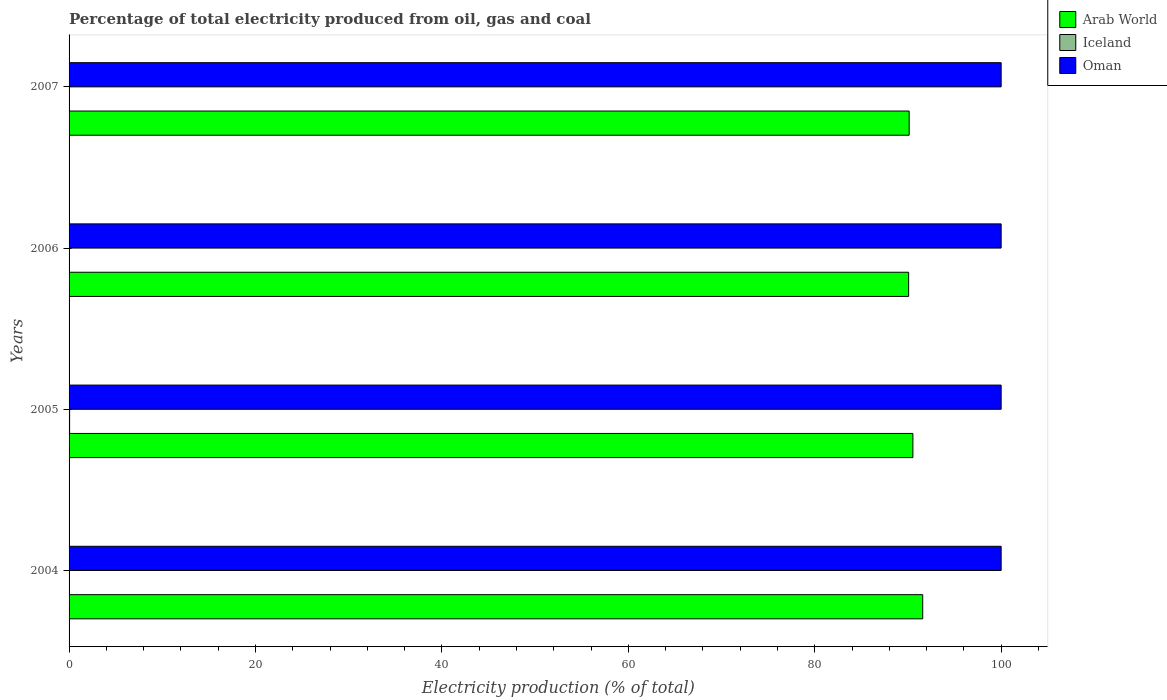Are the number of bars per tick equal to the number of legend labels?
Offer a very short reply. Yes. What is the label of the 1st group of bars from the top?
Your answer should be compact. 2007. What is the electricity production in in Iceland in 2007?
Provide a short and direct response. 0.02. Across all years, what is the minimum electricity production in in Arab World?
Keep it short and to the point. 90.07. In which year was the electricity production in in Iceland minimum?
Your answer should be compact. 2007. What is the total electricity production in in Arab World in the graph?
Keep it short and to the point. 362.32. What is the difference between the electricity production in in Iceland in 2004 and the electricity production in in Arab World in 2005?
Your response must be concise. -90.48. In the year 2007, what is the difference between the electricity production in in Arab World and electricity production in in Iceland?
Keep it short and to the point. 90.11. What is the ratio of the electricity production in in Arab World in 2004 to that in 2007?
Make the answer very short. 1.02. Is the difference between the electricity production in in Arab World in 2004 and 2005 greater than the difference between the electricity production in in Iceland in 2004 and 2005?
Your answer should be very brief. Yes. What is the difference between the highest and the second highest electricity production in in Arab World?
Offer a very short reply. 1.05. What is the difference between the highest and the lowest electricity production in in Oman?
Offer a very short reply. 0. What does the 3rd bar from the top in 2004 represents?
Your response must be concise. Arab World. What does the 1st bar from the bottom in 2004 represents?
Your answer should be very brief. Arab World. Is it the case that in every year, the sum of the electricity production in in Oman and electricity production in in Arab World is greater than the electricity production in in Iceland?
Offer a terse response. Yes. Are the values on the major ticks of X-axis written in scientific E-notation?
Provide a short and direct response. No. Does the graph contain grids?
Make the answer very short. No. What is the title of the graph?
Offer a terse response. Percentage of total electricity produced from oil, gas and coal. What is the label or title of the X-axis?
Your response must be concise. Electricity production (% of total). What is the label or title of the Y-axis?
Make the answer very short. Years. What is the Electricity production (% of total) of Arab World in 2004?
Provide a short and direct response. 91.59. What is the Electricity production (% of total) in Iceland in 2004?
Ensure brevity in your answer.  0.05. What is the Electricity production (% of total) of Oman in 2004?
Ensure brevity in your answer.  100. What is the Electricity production (% of total) in Arab World in 2005?
Keep it short and to the point. 90.53. What is the Electricity production (% of total) of Iceland in 2005?
Your answer should be compact. 0.06. What is the Electricity production (% of total) in Arab World in 2006?
Your response must be concise. 90.07. What is the Electricity production (% of total) in Iceland in 2006?
Make the answer very short. 0.04. What is the Electricity production (% of total) of Oman in 2006?
Your response must be concise. 100. What is the Electricity production (% of total) in Arab World in 2007?
Your response must be concise. 90.13. What is the Electricity production (% of total) of Iceland in 2007?
Keep it short and to the point. 0.02. Across all years, what is the maximum Electricity production (% of total) of Arab World?
Offer a terse response. 91.59. Across all years, what is the maximum Electricity production (% of total) of Iceland?
Give a very brief answer. 0.06. Across all years, what is the maximum Electricity production (% of total) in Oman?
Offer a very short reply. 100. Across all years, what is the minimum Electricity production (% of total) of Arab World?
Give a very brief answer. 90.07. Across all years, what is the minimum Electricity production (% of total) of Iceland?
Your answer should be very brief. 0.02. Across all years, what is the minimum Electricity production (% of total) of Oman?
Your response must be concise. 100. What is the total Electricity production (% of total) of Arab World in the graph?
Your response must be concise. 362.32. What is the total Electricity production (% of total) of Iceland in the graph?
Provide a succinct answer. 0.16. What is the total Electricity production (% of total) of Oman in the graph?
Ensure brevity in your answer.  400. What is the difference between the Electricity production (% of total) of Arab World in 2004 and that in 2005?
Your answer should be compact. 1.05. What is the difference between the Electricity production (% of total) in Iceland in 2004 and that in 2005?
Offer a very short reply. -0.01. What is the difference between the Electricity production (% of total) in Arab World in 2004 and that in 2006?
Your answer should be very brief. 1.51. What is the difference between the Electricity production (% of total) of Iceland in 2004 and that in 2006?
Offer a very short reply. 0.01. What is the difference between the Electricity production (% of total) in Oman in 2004 and that in 2006?
Offer a very short reply. 0. What is the difference between the Electricity production (% of total) of Arab World in 2004 and that in 2007?
Keep it short and to the point. 1.46. What is the difference between the Electricity production (% of total) in Iceland in 2004 and that in 2007?
Your answer should be compact. 0.03. What is the difference between the Electricity production (% of total) in Oman in 2004 and that in 2007?
Provide a succinct answer. 0. What is the difference between the Electricity production (% of total) of Arab World in 2005 and that in 2006?
Offer a terse response. 0.46. What is the difference between the Electricity production (% of total) in Iceland in 2005 and that in 2006?
Offer a terse response. 0.02. What is the difference between the Electricity production (% of total) in Oman in 2005 and that in 2006?
Your answer should be very brief. 0. What is the difference between the Electricity production (% of total) in Arab World in 2005 and that in 2007?
Make the answer very short. 0.4. What is the difference between the Electricity production (% of total) in Iceland in 2005 and that in 2007?
Provide a short and direct response. 0.04. What is the difference between the Electricity production (% of total) in Oman in 2005 and that in 2007?
Your answer should be compact. 0. What is the difference between the Electricity production (% of total) of Arab World in 2006 and that in 2007?
Offer a very short reply. -0.06. What is the difference between the Electricity production (% of total) of Iceland in 2006 and that in 2007?
Provide a short and direct response. 0.02. What is the difference between the Electricity production (% of total) in Arab World in 2004 and the Electricity production (% of total) in Iceland in 2005?
Your answer should be compact. 91.53. What is the difference between the Electricity production (% of total) of Arab World in 2004 and the Electricity production (% of total) of Oman in 2005?
Your answer should be very brief. -8.41. What is the difference between the Electricity production (% of total) in Iceland in 2004 and the Electricity production (% of total) in Oman in 2005?
Make the answer very short. -99.95. What is the difference between the Electricity production (% of total) of Arab World in 2004 and the Electricity production (% of total) of Iceland in 2006?
Your answer should be very brief. 91.55. What is the difference between the Electricity production (% of total) in Arab World in 2004 and the Electricity production (% of total) in Oman in 2006?
Your answer should be compact. -8.41. What is the difference between the Electricity production (% of total) of Iceland in 2004 and the Electricity production (% of total) of Oman in 2006?
Keep it short and to the point. -99.95. What is the difference between the Electricity production (% of total) in Arab World in 2004 and the Electricity production (% of total) in Iceland in 2007?
Your answer should be very brief. 91.57. What is the difference between the Electricity production (% of total) in Arab World in 2004 and the Electricity production (% of total) in Oman in 2007?
Make the answer very short. -8.41. What is the difference between the Electricity production (% of total) in Iceland in 2004 and the Electricity production (% of total) in Oman in 2007?
Make the answer very short. -99.95. What is the difference between the Electricity production (% of total) of Arab World in 2005 and the Electricity production (% of total) of Iceland in 2006?
Your answer should be compact. 90.49. What is the difference between the Electricity production (% of total) in Arab World in 2005 and the Electricity production (% of total) in Oman in 2006?
Provide a short and direct response. -9.47. What is the difference between the Electricity production (% of total) of Iceland in 2005 and the Electricity production (% of total) of Oman in 2006?
Make the answer very short. -99.94. What is the difference between the Electricity production (% of total) of Arab World in 2005 and the Electricity production (% of total) of Iceland in 2007?
Make the answer very short. 90.51. What is the difference between the Electricity production (% of total) of Arab World in 2005 and the Electricity production (% of total) of Oman in 2007?
Your answer should be compact. -9.47. What is the difference between the Electricity production (% of total) in Iceland in 2005 and the Electricity production (% of total) in Oman in 2007?
Your answer should be very brief. -99.94. What is the difference between the Electricity production (% of total) in Arab World in 2006 and the Electricity production (% of total) in Iceland in 2007?
Your answer should be very brief. 90.06. What is the difference between the Electricity production (% of total) in Arab World in 2006 and the Electricity production (% of total) in Oman in 2007?
Your answer should be compact. -9.93. What is the difference between the Electricity production (% of total) of Iceland in 2006 and the Electricity production (% of total) of Oman in 2007?
Give a very brief answer. -99.96. What is the average Electricity production (% of total) of Arab World per year?
Your response must be concise. 90.58. What is the average Electricity production (% of total) of Iceland per year?
Provide a short and direct response. 0.04. In the year 2004, what is the difference between the Electricity production (% of total) of Arab World and Electricity production (% of total) of Iceland?
Keep it short and to the point. 91.54. In the year 2004, what is the difference between the Electricity production (% of total) in Arab World and Electricity production (% of total) in Oman?
Offer a terse response. -8.41. In the year 2004, what is the difference between the Electricity production (% of total) of Iceland and Electricity production (% of total) of Oman?
Offer a terse response. -99.95. In the year 2005, what is the difference between the Electricity production (% of total) of Arab World and Electricity production (% of total) of Iceland?
Give a very brief answer. 90.47. In the year 2005, what is the difference between the Electricity production (% of total) of Arab World and Electricity production (% of total) of Oman?
Make the answer very short. -9.47. In the year 2005, what is the difference between the Electricity production (% of total) of Iceland and Electricity production (% of total) of Oman?
Your response must be concise. -99.94. In the year 2006, what is the difference between the Electricity production (% of total) in Arab World and Electricity production (% of total) in Iceland?
Ensure brevity in your answer.  90.03. In the year 2006, what is the difference between the Electricity production (% of total) in Arab World and Electricity production (% of total) in Oman?
Offer a very short reply. -9.93. In the year 2006, what is the difference between the Electricity production (% of total) in Iceland and Electricity production (% of total) in Oman?
Your answer should be very brief. -99.96. In the year 2007, what is the difference between the Electricity production (% of total) in Arab World and Electricity production (% of total) in Iceland?
Provide a short and direct response. 90.11. In the year 2007, what is the difference between the Electricity production (% of total) in Arab World and Electricity production (% of total) in Oman?
Your answer should be compact. -9.87. In the year 2007, what is the difference between the Electricity production (% of total) in Iceland and Electricity production (% of total) in Oman?
Your answer should be compact. -99.98. What is the ratio of the Electricity production (% of total) of Arab World in 2004 to that in 2005?
Provide a succinct answer. 1.01. What is the ratio of the Electricity production (% of total) of Iceland in 2004 to that in 2005?
Provide a succinct answer. 0.81. What is the ratio of the Electricity production (% of total) in Arab World in 2004 to that in 2006?
Offer a terse response. 1.02. What is the ratio of the Electricity production (% of total) of Iceland in 2004 to that in 2006?
Provide a succinct answer. 1.15. What is the ratio of the Electricity production (% of total) of Oman in 2004 to that in 2006?
Ensure brevity in your answer.  1. What is the ratio of the Electricity production (% of total) of Arab World in 2004 to that in 2007?
Your answer should be very brief. 1.02. What is the ratio of the Electricity production (% of total) of Iceland in 2004 to that in 2007?
Keep it short and to the point. 2.78. What is the ratio of the Electricity production (% of total) of Oman in 2004 to that in 2007?
Offer a very short reply. 1. What is the ratio of the Electricity production (% of total) of Iceland in 2005 to that in 2006?
Keep it short and to the point. 1.43. What is the ratio of the Electricity production (% of total) in Oman in 2005 to that in 2006?
Give a very brief answer. 1. What is the ratio of the Electricity production (% of total) in Arab World in 2005 to that in 2007?
Your answer should be compact. 1. What is the ratio of the Electricity production (% of total) in Iceland in 2005 to that in 2007?
Make the answer very short. 3.45. What is the ratio of the Electricity production (% of total) in Oman in 2005 to that in 2007?
Keep it short and to the point. 1. What is the ratio of the Electricity production (% of total) in Arab World in 2006 to that in 2007?
Make the answer very short. 1. What is the ratio of the Electricity production (% of total) in Iceland in 2006 to that in 2007?
Provide a short and direct response. 2.41. What is the ratio of the Electricity production (% of total) of Oman in 2006 to that in 2007?
Provide a short and direct response. 1. What is the difference between the highest and the second highest Electricity production (% of total) in Arab World?
Offer a very short reply. 1.05. What is the difference between the highest and the second highest Electricity production (% of total) of Iceland?
Keep it short and to the point. 0.01. What is the difference between the highest and the lowest Electricity production (% of total) of Arab World?
Give a very brief answer. 1.51. What is the difference between the highest and the lowest Electricity production (% of total) in Iceland?
Your response must be concise. 0.04. What is the difference between the highest and the lowest Electricity production (% of total) in Oman?
Provide a succinct answer. 0. 